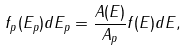<formula> <loc_0><loc_0><loc_500><loc_500>f _ { p } ( E _ { p } ) d E _ { p } = \frac { A ( E ) } { A _ { p } } f ( E ) d E ,</formula> 